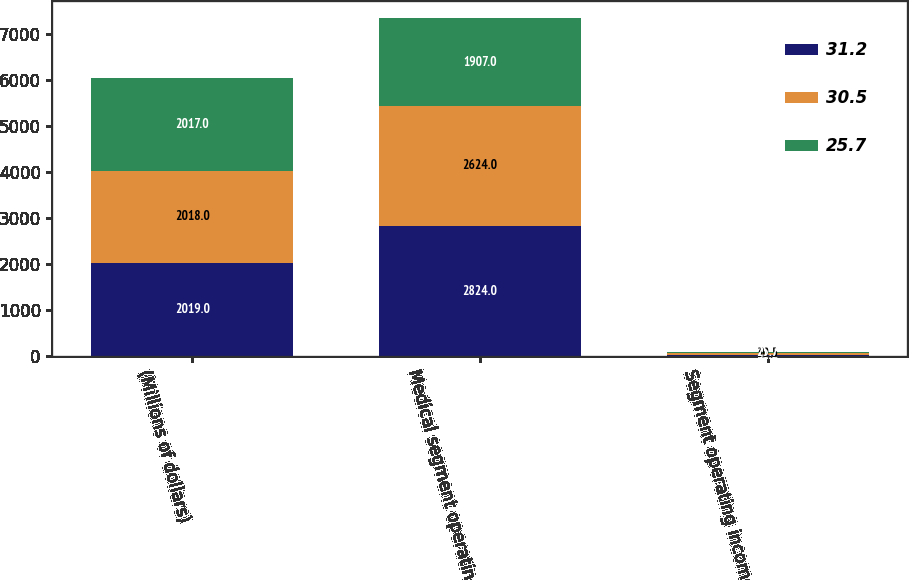Convert chart to OTSL. <chart><loc_0><loc_0><loc_500><loc_500><stacked_bar_chart><ecel><fcel>(Millions of dollars)<fcel>Medical segment operating<fcel>Segment operating income as of<nl><fcel>31.2<fcel>2019<fcel>2824<fcel>31.2<nl><fcel>30.5<fcel>2018<fcel>2624<fcel>30.5<nl><fcel>25.7<fcel>2017<fcel>1907<fcel>25.7<nl></chart> 